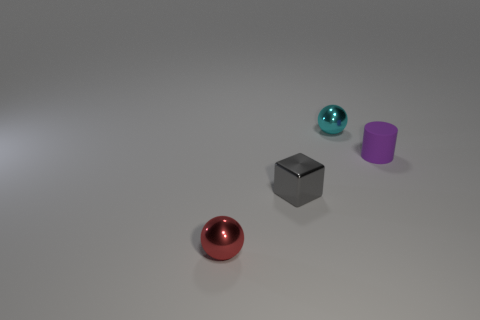Add 3 green metal spheres. How many objects exist? 7 Subtract all blocks. How many objects are left? 3 Add 1 small gray shiny blocks. How many small gray shiny blocks exist? 2 Subtract 0 blue cylinders. How many objects are left? 4 Subtract all blue spheres. Subtract all tiny gray shiny cubes. How many objects are left? 3 Add 2 tiny cyan metal things. How many tiny cyan metal things are left? 3 